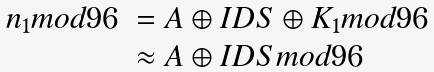<formula> <loc_0><loc_0><loc_500><loc_500>\begin{array} { l l } n _ { 1 } m o d 9 6 & = A \oplus I D S \oplus K _ { 1 } m o d 9 6 \\ & \approx A \oplus I D S m o d 9 6 \end{array}</formula> 